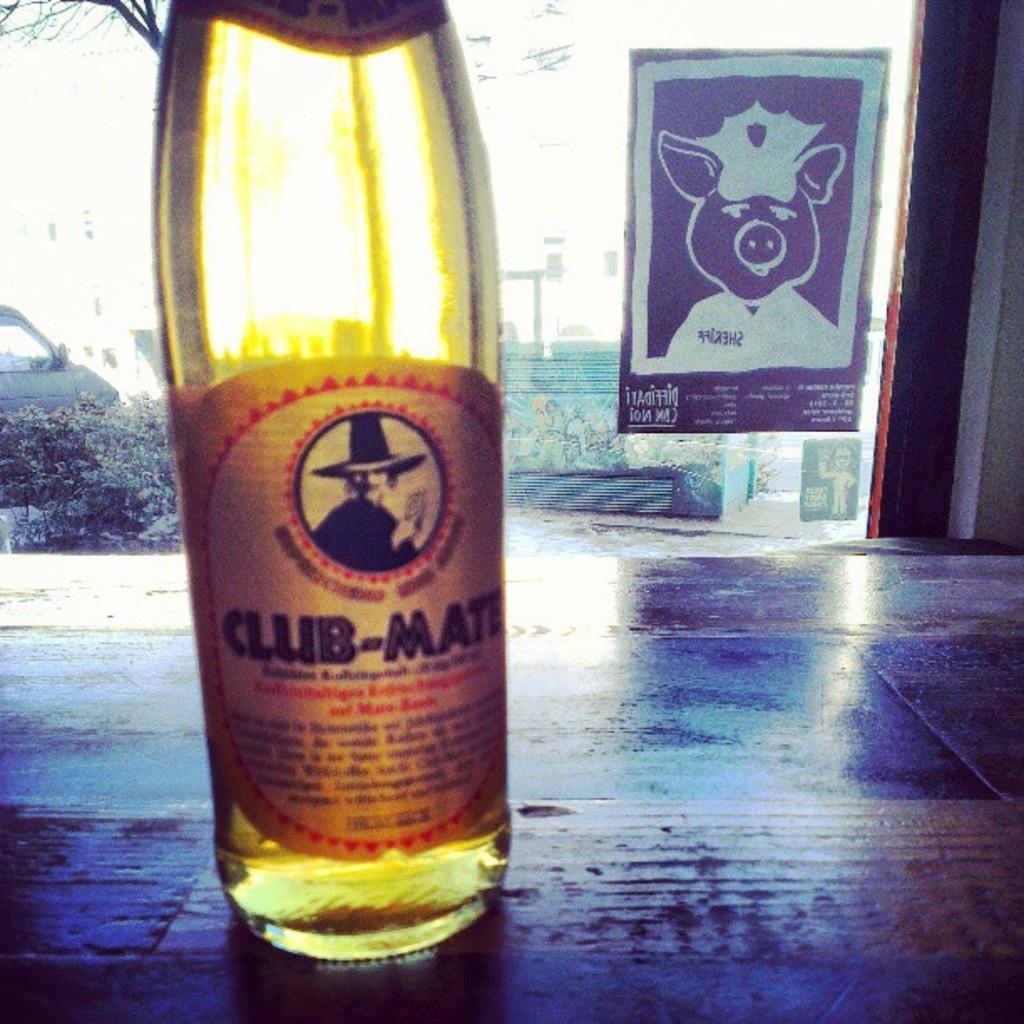Can you describe this image briefly? In this image one bottle is placing on the table and behind the bottle there is one car and plants are there and the background is sunny. 